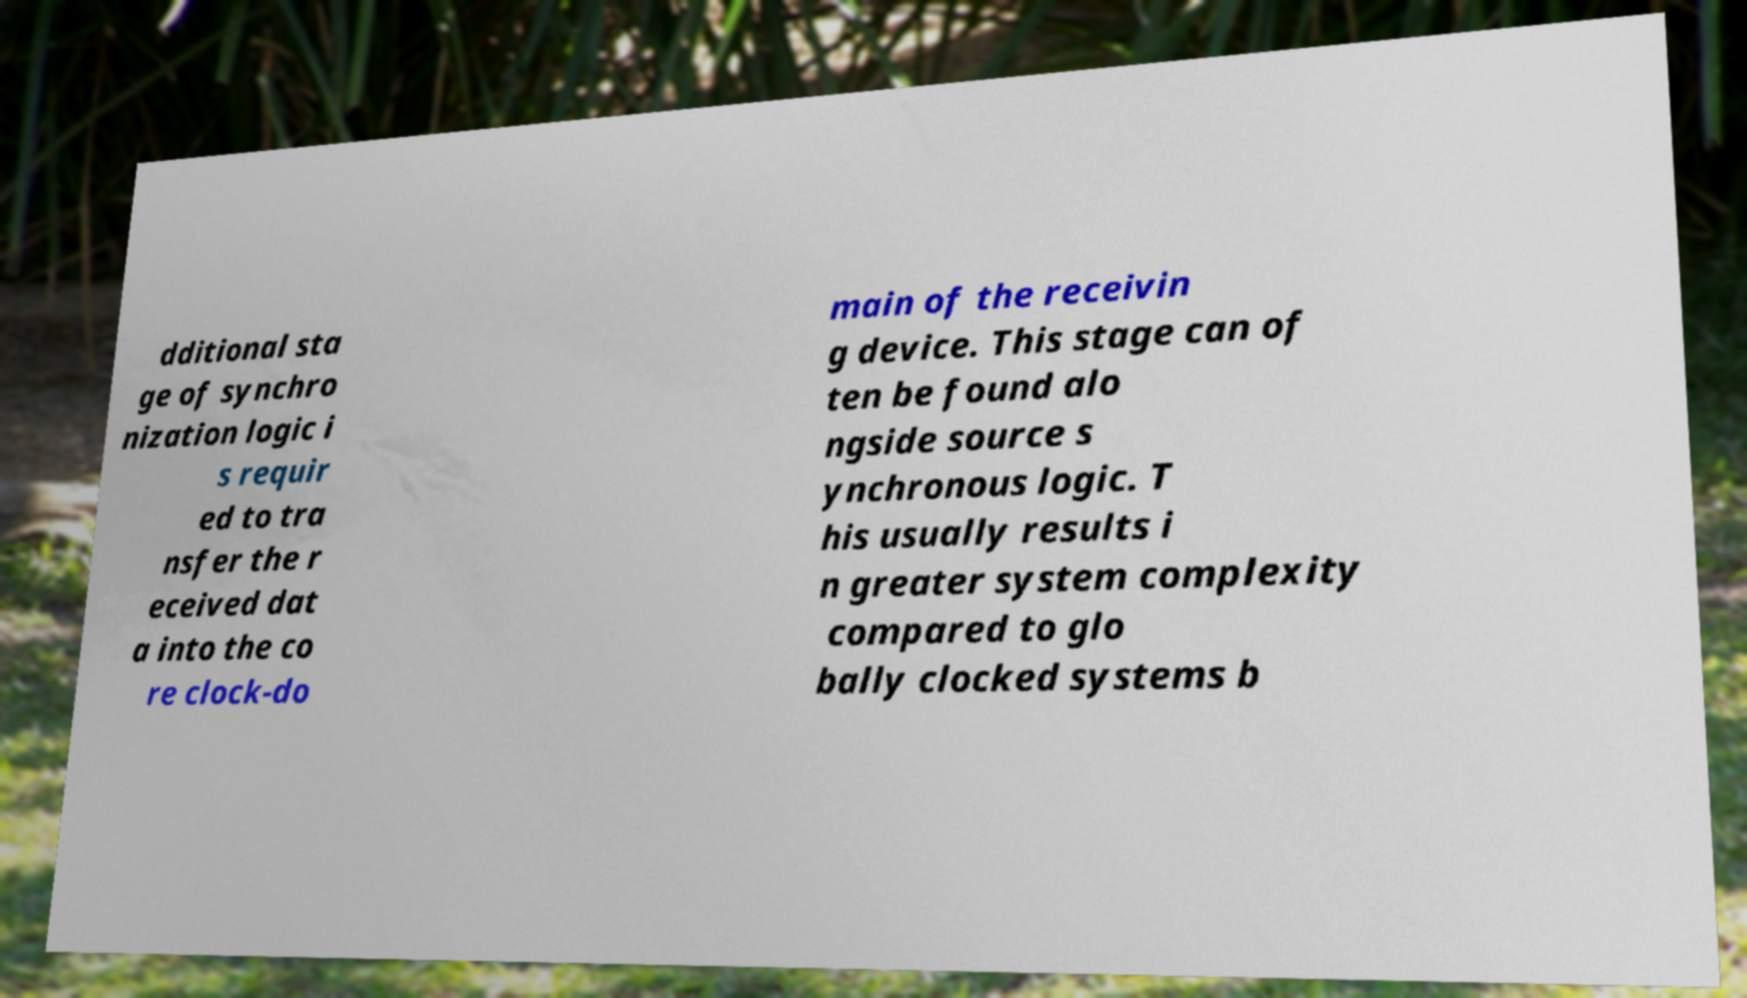Could you extract and type out the text from this image? dditional sta ge of synchro nization logic i s requir ed to tra nsfer the r eceived dat a into the co re clock-do main of the receivin g device. This stage can of ten be found alo ngside source s ynchronous logic. T his usually results i n greater system complexity compared to glo bally clocked systems b 